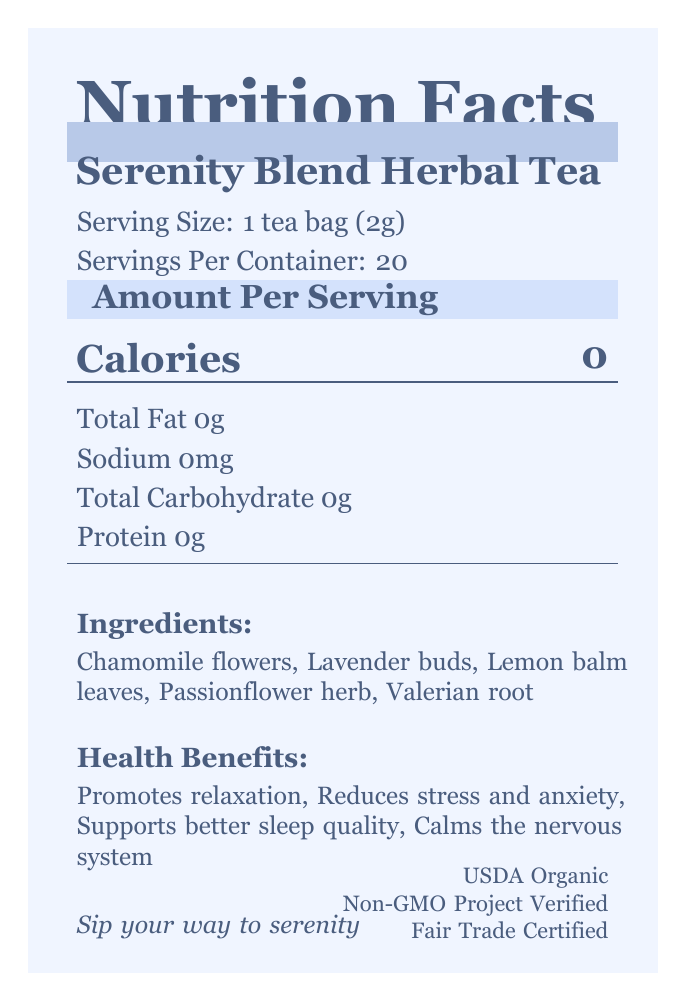what is the serving size for Serenity Blend Herbal Tea? The serving size is clearly stated in the document as "Serving Size: 1 tea bag (2g)".
Answer: 1 tea bag (2g) how many calories are in one serving of Serenity Blend Herbal Tea? The document lists "Calories: 0" under the Amount Per Serving section.
Answer: 0 what are the main ingredients in Serenity Blend Herbal Tea? The Ingredients section lists these five components.
Answer: Chamomile flowers, Lavender buds, Lemon balm leaves, Passionflower herb, Valerian root how long should you steep the tea for optimal flavor? The brewing instructions specify to steep in hot water (180°F) for 5-7 minutes.
Answer: 5-7 minutes how many servings are there per container? The document indicates "Servings Per Container: 20".
Answer: 20 what certifications does the Serenity Blend Herbal Tea have? The certifications are listed at the end of the document.
Answer: USDA Organic, Non-GMO Project Verified, Fair Trade Certified what color is used for the document's background? A. #FFFFFF B. #D4E2FC C. #B8C9E8 D. #F0F5FF The background color is defined in the color_palette as "#F0F5FF".
Answer: D. #F0F5FF which statement is true regarding the health benefits of Serenity Blend Herbal Tea? I. It supports better sleep quality. II. It contains a high amount of calories. III. It reduces stress and anxiety. The health benefits section lists "Supports better sleep quality" and "Reduces stress and anxiety," but the tea contains 0 calories.
Answer: I and III is the Serenity Blend Herbal Tea caffeine-free? The additional info section states "caffeine-free."
Answer: Yes summarize the main idea of the Serenity Blend Herbal Tea nutrition facts label. The document provides detailed nutritional information, health benefits, ingredients, brewing instructions, and certifications for Serenity Blend Herbal Tea, with an emphasis on relaxation and stress reduction.
Answer: The Serenity Blend Herbal Tea is an organic, caffeine-free herbal tea blend designed to promote relaxation, reduce stress, and support better sleep quality. It has 0 calories and contains natural ingredients such as Chamomile flowers, Lavender buds, Lemon balm leaves, Passionflower herb, and Valerian root. The product is certified USDA Organic, Non-GMO Project Verified, and Fair Trade Certified. Visual elements use soothing pastel colors to evoke a sense of calm. what is the expiration date of Serenity Blend Herbal Tea? The document doesn't provide a specific expiration date, only that it is best if used within 18 months of the production date.
Answer: Not enough information what tagline is used to promote Serenity Blend Herbal Tea? The tagline is at the bottom, stating "Sip your way to serenity."
Answer: Sip your way to serenity 